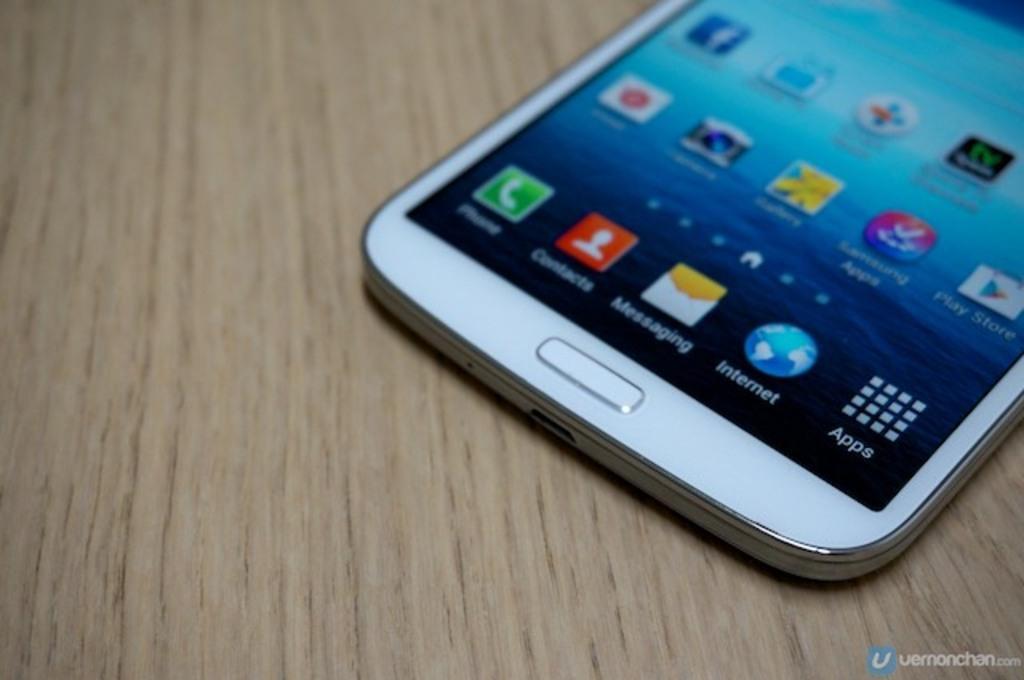In one or two sentences, can you explain what this image depicts? In the picture I can see a mobile phone is kept on the wooden table. On the screen of a mobile phone I can see the application icons. 